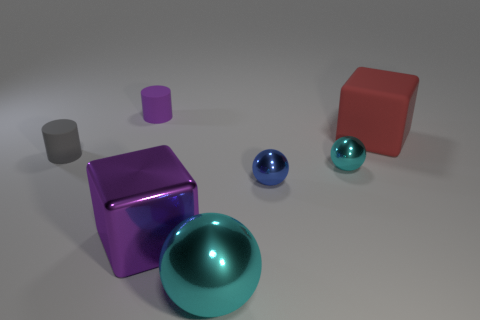Are the large thing that is to the right of the large cyan object and the gray object made of the same material?
Your answer should be very brief. Yes. How many things are either small rubber cylinders behind the gray thing or blue matte spheres?
Your answer should be compact. 1. There is a small cylinder that is the same material as the tiny purple object; what color is it?
Offer a very short reply. Gray. Is there a red block that has the same size as the blue metallic ball?
Your answer should be compact. No. Do the big block on the right side of the blue metallic ball and the large metallic sphere have the same color?
Offer a terse response. No. There is a large thing that is both to the right of the purple cube and in front of the large matte block; what is its color?
Provide a succinct answer. Cyan. There is a gray object that is the same size as the blue shiny ball; what is its shape?
Provide a succinct answer. Cylinder. Is there a cyan metal thing that has the same shape as the small gray object?
Provide a succinct answer. No. There is a object behind the red matte cube; is its size the same as the small blue metal thing?
Make the answer very short. Yes. There is a object that is behind the tiny blue ball and in front of the small gray object; how big is it?
Your answer should be compact. Small. 